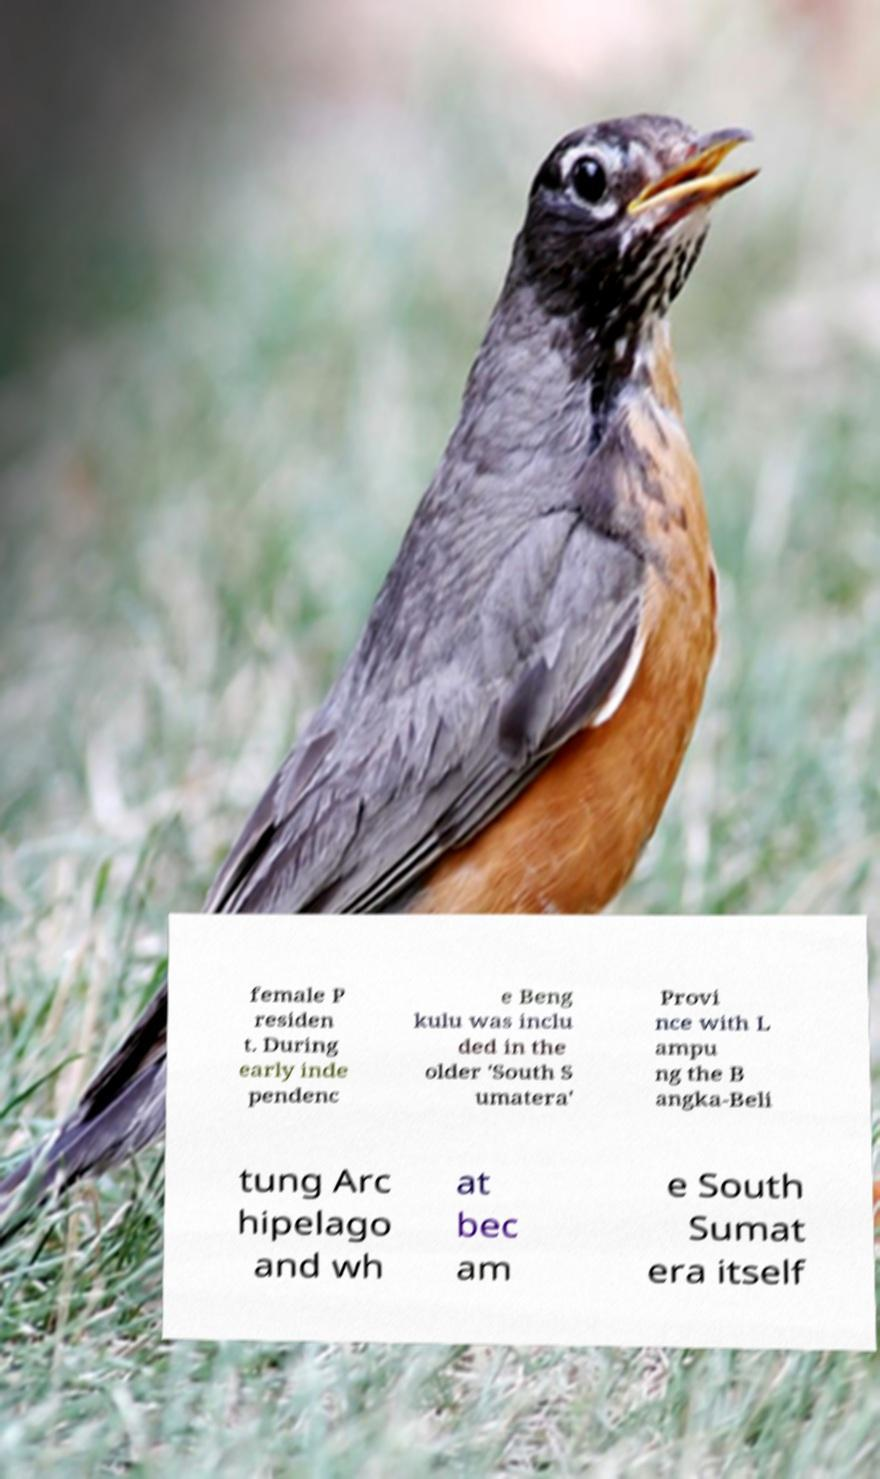What messages or text are displayed in this image? I need them in a readable, typed format. female P residen t. During early inde pendenc e Beng kulu was inclu ded in the older 'South S umatera' Provi nce with L ampu ng the B angka-Beli tung Arc hipelago and wh at bec am e South Sumat era itself 